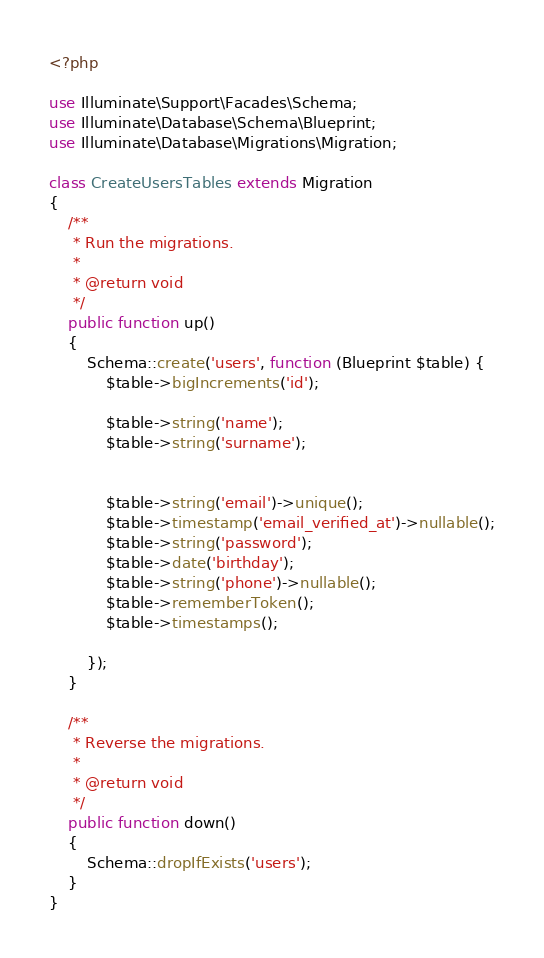Convert code to text. <code><loc_0><loc_0><loc_500><loc_500><_PHP_><?php

use Illuminate\Support\Facades\Schema;
use Illuminate\Database\Schema\Blueprint;
use Illuminate\Database\Migrations\Migration;

class CreateUsersTables extends Migration
{
    /**
     * Run the migrations.
     *
     * @return void
     */
    public function up()
    {
        Schema::create('users', function (Blueprint $table) {
            $table->bigIncrements('id');

            $table->string('name');
            $table->string('surname');


            $table->string('email')->unique();
            $table->timestamp('email_verified_at')->nullable();
            $table->string('password');
            $table->date('birthday');
            $table->string('phone')->nullable();
            $table->rememberToken();
            $table->timestamps();

        });
    }

    /**
     * Reverse the migrations.
     *
     * @return void
     */
    public function down()
    {
        Schema::dropIfExists('users');
    }
}
</code> 